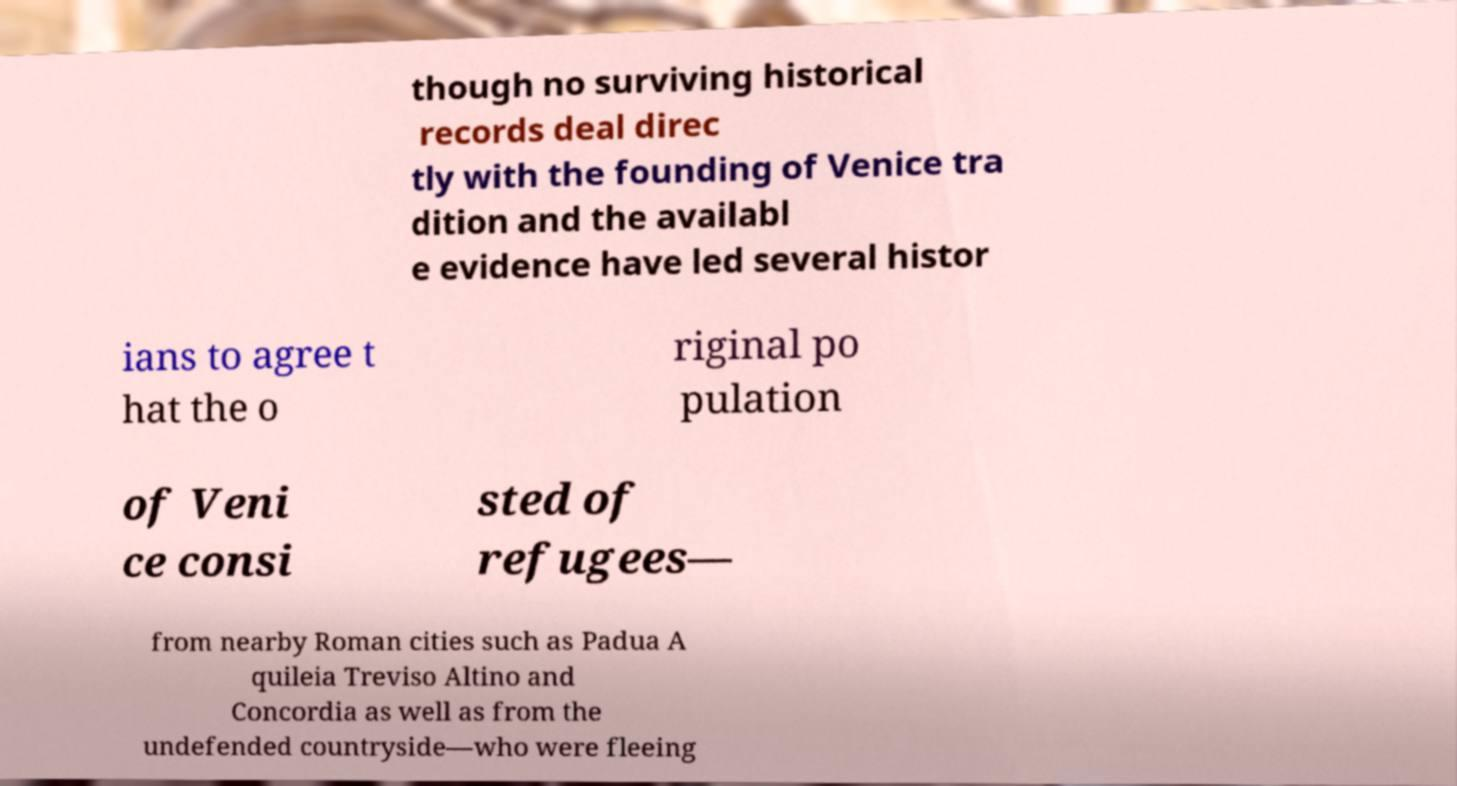Can you read and provide the text displayed in the image?This photo seems to have some interesting text. Can you extract and type it out for me? though no surviving historical records deal direc tly with the founding of Venice tra dition and the availabl e evidence have led several histor ians to agree t hat the o riginal po pulation of Veni ce consi sted of refugees— from nearby Roman cities such as Padua A quileia Treviso Altino and Concordia as well as from the undefended countryside—who were fleeing 